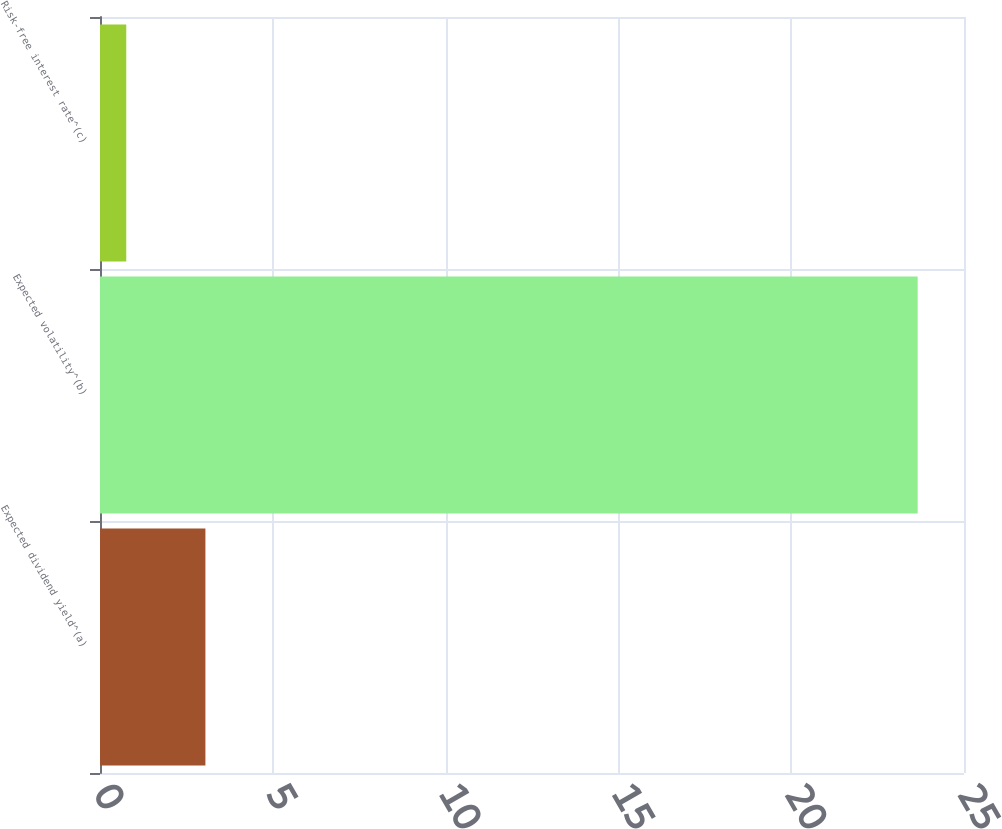Convert chart. <chart><loc_0><loc_0><loc_500><loc_500><bar_chart><fcel>Expected dividend yield^(a)<fcel>Expected volatility^(b)<fcel>Risk-free interest rate^(c)<nl><fcel>3.05<fcel>23.66<fcel>0.76<nl></chart> 